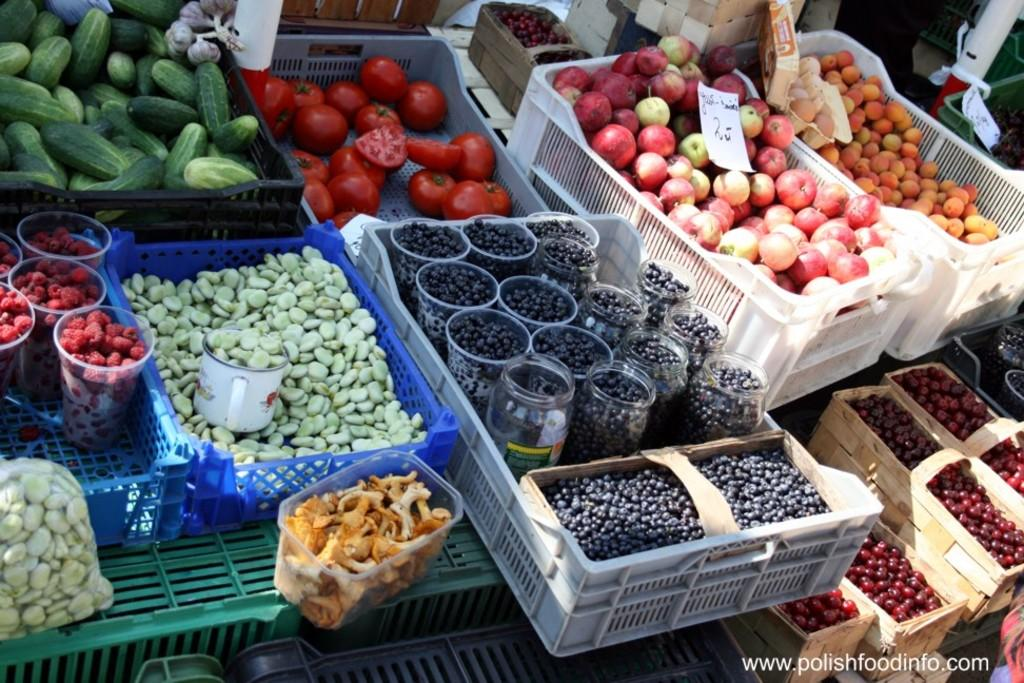What types of food items can be seen in the image? There are vegetables and fruits in the image. How are the vegetables and fruits arranged in the image? The vegetables and fruits are in trays. Are there any other objects visible in the image besides the vegetables and fruits? Yes, there are other objects in the image. Can you describe any additional details about the image? There are watermarks on the bottom right side of the image. Can you see a yak eating the fruits in the image? No, there is no yak present in the image. 